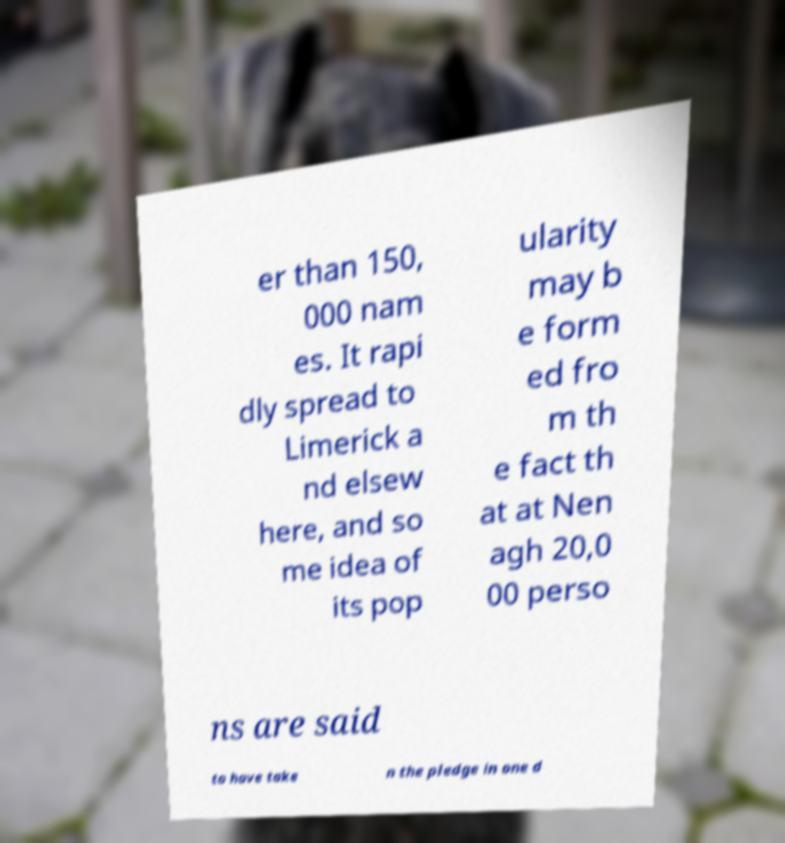Please identify and transcribe the text found in this image. er than 150, 000 nam es. It rapi dly spread to Limerick a nd elsew here, and so me idea of its pop ularity may b e form ed fro m th e fact th at at Nen agh 20,0 00 perso ns are said to have take n the pledge in one d 